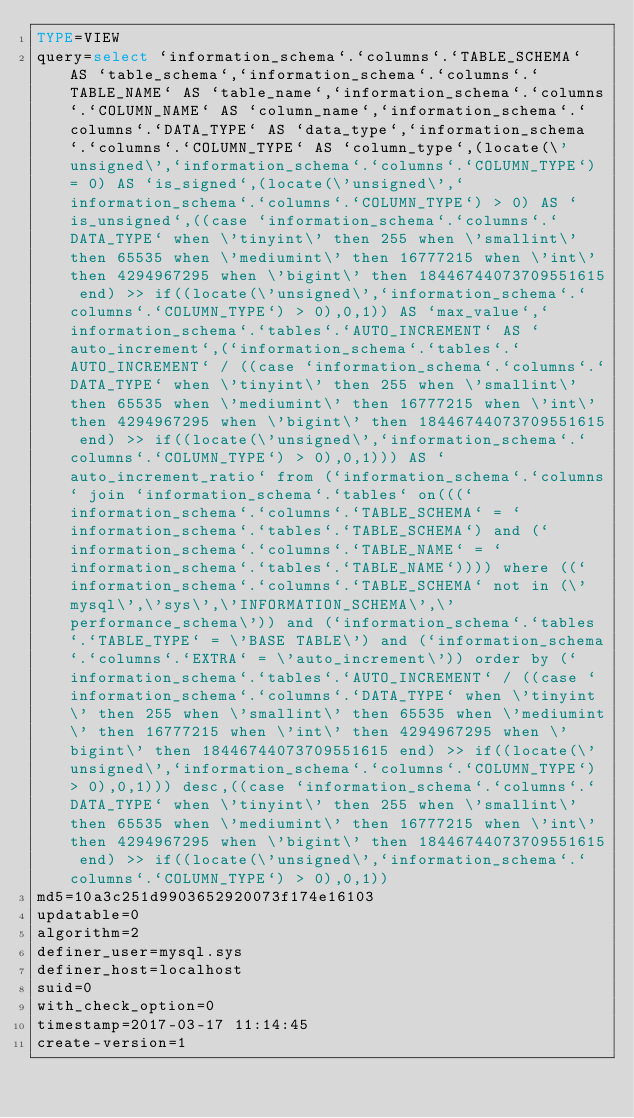Convert code to text. <code><loc_0><loc_0><loc_500><loc_500><_VisualBasic_>TYPE=VIEW
query=select `information_schema`.`columns`.`TABLE_SCHEMA` AS `table_schema`,`information_schema`.`columns`.`TABLE_NAME` AS `table_name`,`information_schema`.`columns`.`COLUMN_NAME` AS `column_name`,`information_schema`.`columns`.`DATA_TYPE` AS `data_type`,`information_schema`.`columns`.`COLUMN_TYPE` AS `column_type`,(locate(\'unsigned\',`information_schema`.`columns`.`COLUMN_TYPE`) = 0) AS `is_signed`,(locate(\'unsigned\',`information_schema`.`columns`.`COLUMN_TYPE`) > 0) AS `is_unsigned`,((case `information_schema`.`columns`.`DATA_TYPE` when \'tinyint\' then 255 when \'smallint\' then 65535 when \'mediumint\' then 16777215 when \'int\' then 4294967295 when \'bigint\' then 18446744073709551615 end) >> if((locate(\'unsigned\',`information_schema`.`columns`.`COLUMN_TYPE`) > 0),0,1)) AS `max_value`,`information_schema`.`tables`.`AUTO_INCREMENT` AS `auto_increment`,(`information_schema`.`tables`.`AUTO_INCREMENT` / ((case `information_schema`.`columns`.`DATA_TYPE` when \'tinyint\' then 255 when \'smallint\' then 65535 when \'mediumint\' then 16777215 when \'int\' then 4294967295 when \'bigint\' then 18446744073709551615 end) >> if((locate(\'unsigned\',`information_schema`.`columns`.`COLUMN_TYPE`) > 0),0,1))) AS `auto_increment_ratio` from (`information_schema`.`columns` join `information_schema`.`tables` on(((`information_schema`.`columns`.`TABLE_SCHEMA` = `information_schema`.`tables`.`TABLE_SCHEMA`) and (`information_schema`.`columns`.`TABLE_NAME` = `information_schema`.`tables`.`TABLE_NAME`)))) where ((`information_schema`.`columns`.`TABLE_SCHEMA` not in (\'mysql\',\'sys\',\'INFORMATION_SCHEMA\',\'performance_schema\')) and (`information_schema`.`tables`.`TABLE_TYPE` = \'BASE TABLE\') and (`information_schema`.`columns`.`EXTRA` = \'auto_increment\')) order by (`information_schema`.`tables`.`AUTO_INCREMENT` / ((case `information_schema`.`columns`.`DATA_TYPE` when \'tinyint\' then 255 when \'smallint\' then 65535 when \'mediumint\' then 16777215 when \'int\' then 4294967295 when \'bigint\' then 18446744073709551615 end) >> if((locate(\'unsigned\',`information_schema`.`columns`.`COLUMN_TYPE`) > 0),0,1))) desc,((case `information_schema`.`columns`.`DATA_TYPE` when \'tinyint\' then 255 when \'smallint\' then 65535 when \'mediumint\' then 16777215 when \'int\' then 4294967295 when \'bigint\' then 18446744073709551615 end) >> if((locate(\'unsigned\',`information_schema`.`columns`.`COLUMN_TYPE`) > 0),0,1))
md5=10a3c251d9903652920073f174e16103
updatable=0
algorithm=2
definer_user=mysql.sys
definer_host=localhost
suid=0
with_check_option=0
timestamp=2017-03-17 11:14:45
create-version=1</code> 